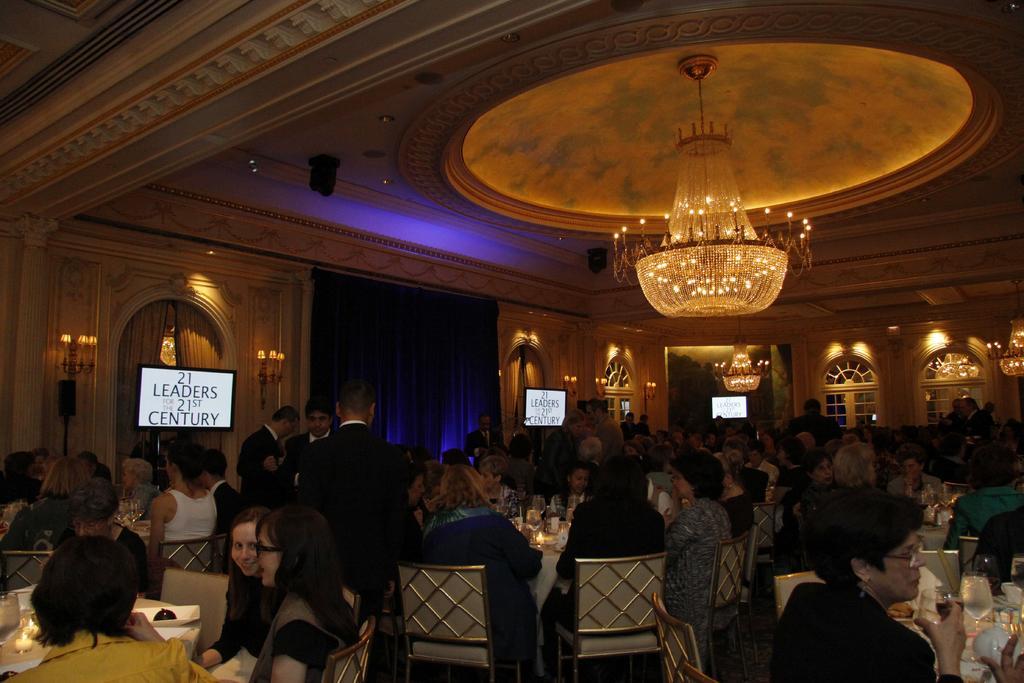In one or two sentences, can you explain what this image depicts? In this image i can see number of people are sitting on chairs. I can also see here a woman is holding a glass and few of them are wearing specs. In the background I can see few screens and few speakers. 